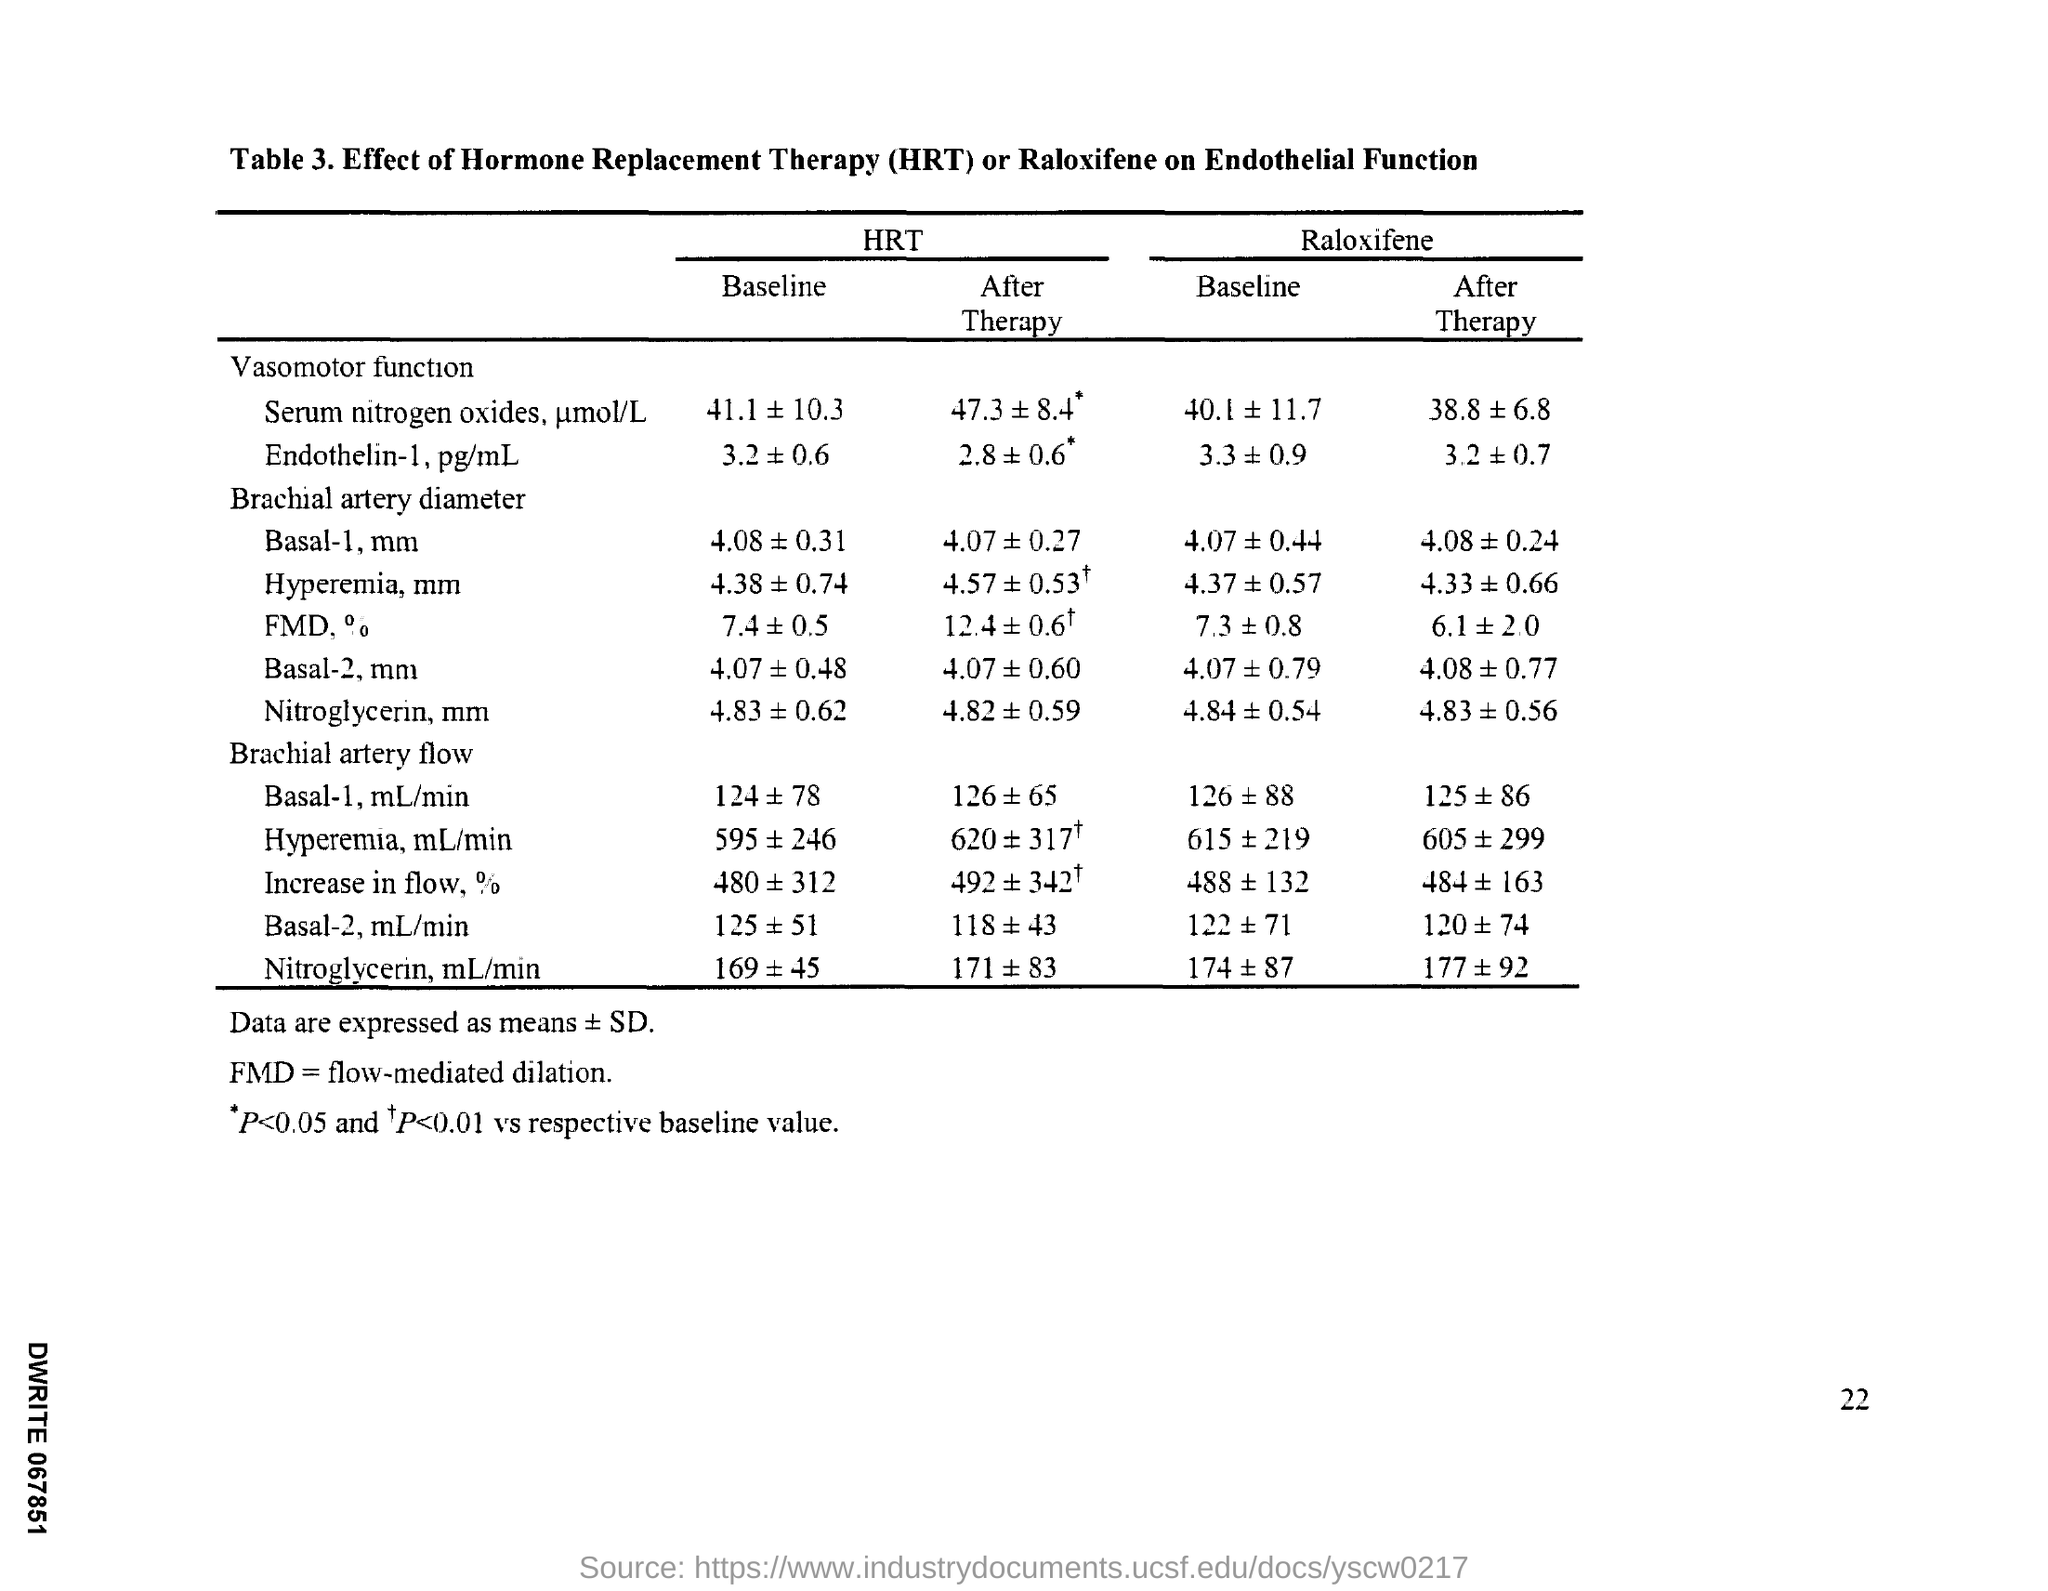Identify some key points in this picture. Flow-mediated dilation is a medical term that refers to the expansion or widening of the blood vessels in response to increased blood flow. The full form of the abbreviation "fmd" is "flow-mediated dilation. Hormone replacement therapy, commonly referred to as HRT, is a medical treatment that involves replacing hormones that are no longer produced in the body, such as estrogen and progesterone, in order to alleviate symptoms associated with hormonal imbalances or deficiencies. The page number is 22," stated the source. 